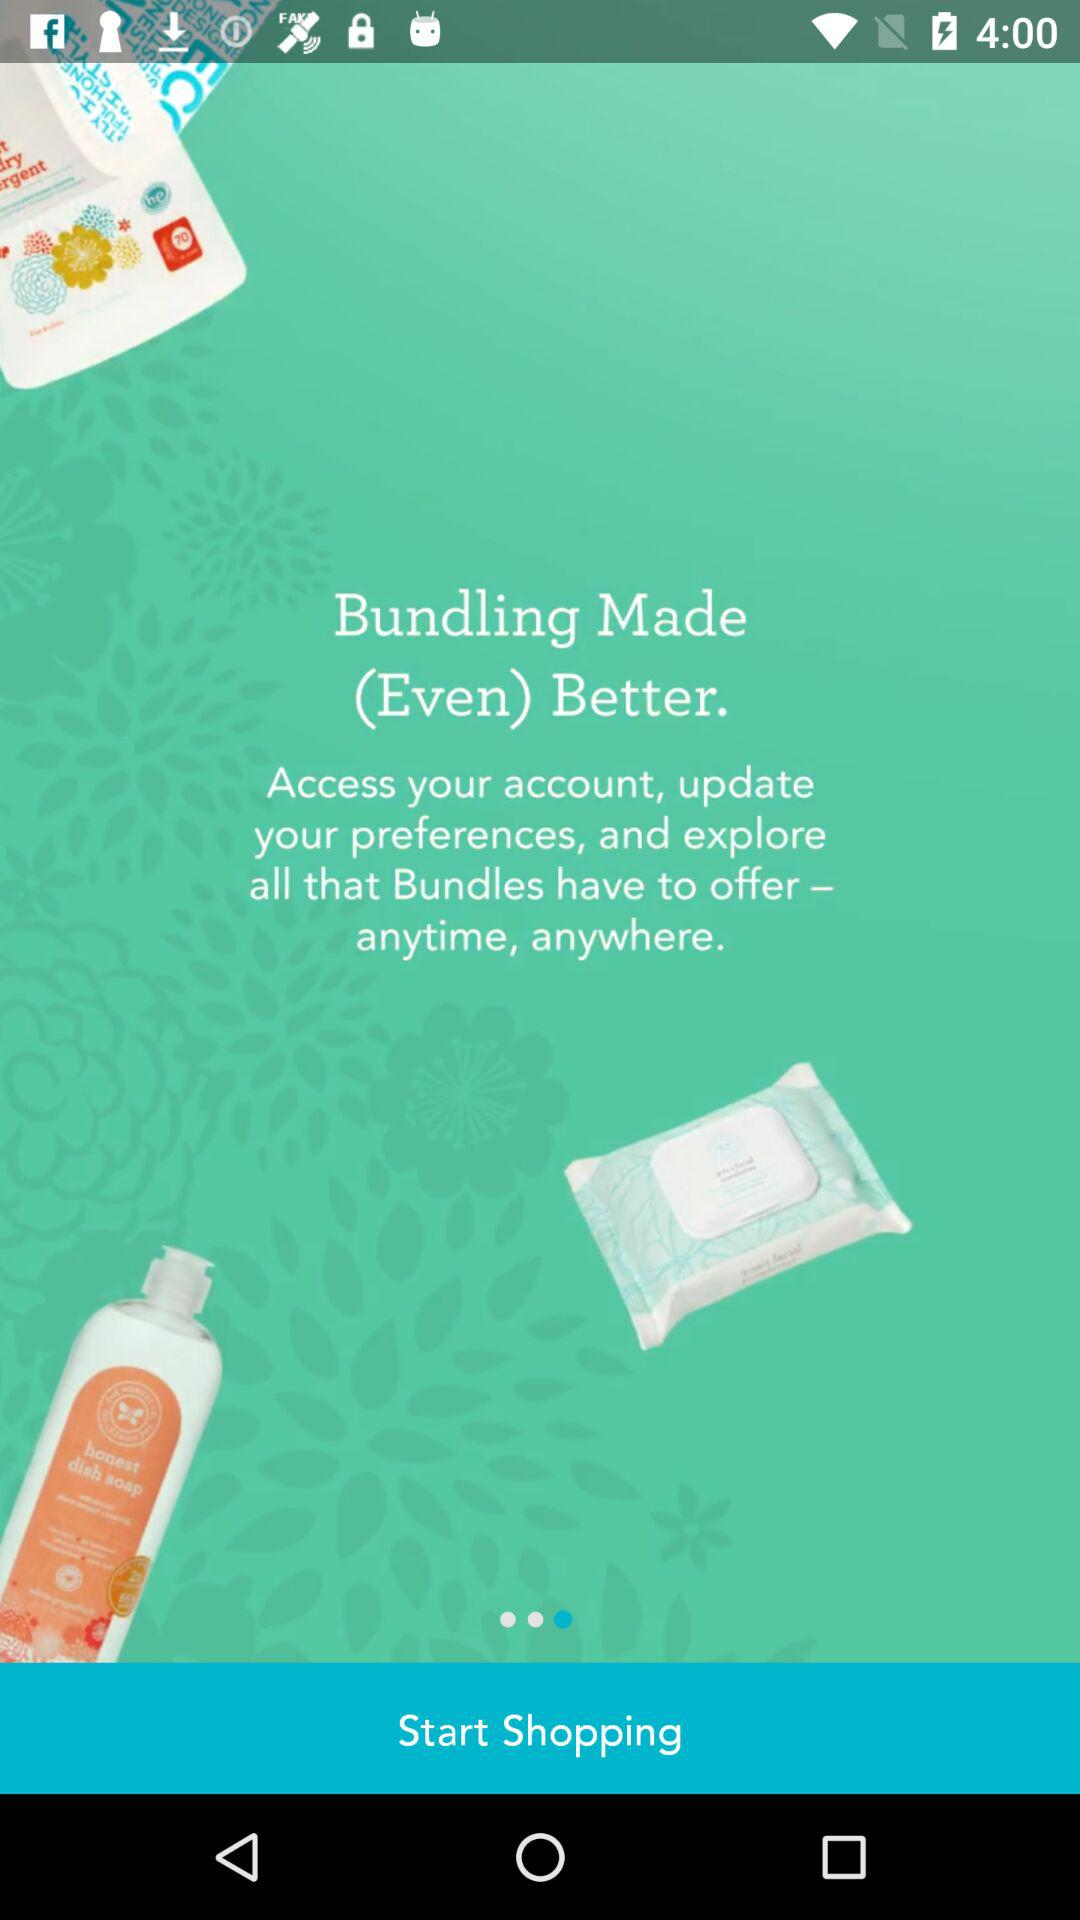How many items are in the bundle?
Answer the question using a single word or phrase. 2 